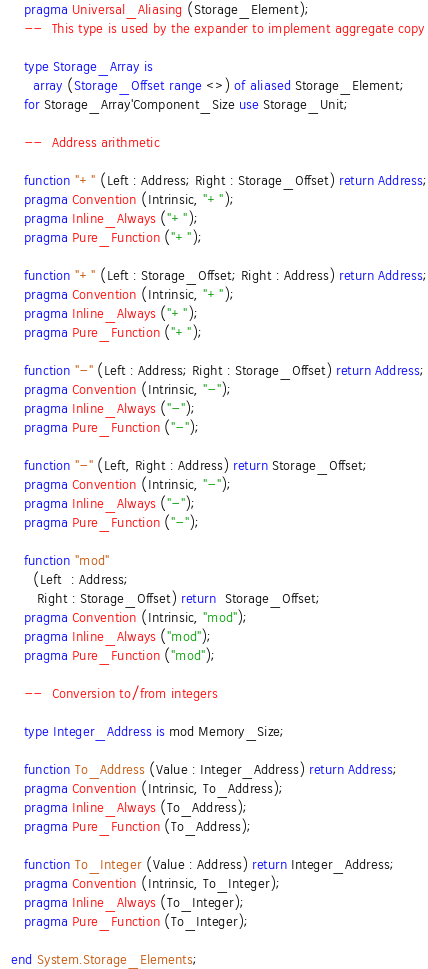Convert code to text. <code><loc_0><loc_0><loc_500><loc_500><_Ada_>   pragma Universal_Aliasing (Storage_Element);
   --  This type is used by the expander to implement aggregate copy

   type Storage_Array is
     array (Storage_Offset range <>) of aliased Storage_Element;
   for Storage_Array'Component_Size use Storage_Unit;

   --  Address arithmetic

   function "+" (Left : Address; Right : Storage_Offset) return Address;
   pragma Convention (Intrinsic, "+");
   pragma Inline_Always ("+");
   pragma Pure_Function ("+");

   function "+" (Left : Storage_Offset; Right : Address) return Address;
   pragma Convention (Intrinsic, "+");
   pragma Inline_Always ("+");
   pragma Pure_Function ("+");

   function "-" (Left : Address; Right : Storage_Offset) return Address;
   pragma Convention (Intrinsic, "-");
   pragma Inline_Always ("-");
   pragma Pure_Function ("-");

   function "-" (Left, Right : Address) return Storage_Offset;
   pragma Convention (Intrinsic, "-");
   pragma Inline_Always ("-");
   pragma Pure_Function ("-");

   function "mod"
     (Left  : Address;
      Right : Storage_Offset) return  Storage_Offset;
   pragma Convention (Intrinsic, "mod");
   pragma Inline_Always ("mod");
   pragma Pure_Function ("mod");

   --  Conversion to/from integers

   type Integer_Address is mod Memory_Size;

   function To_Address (Value : Integer_Address) return Address;
   pragma Convention (Intrinsic, To_Address);
   pragma Inline_Always (To_Address);
   pragma Pure_Function (To_Address);

   function To_Integer (Value : Address) return Integer_Address;
   pragma Convention (Intrinsic, To_Integer);
   pragma Inline_Always (To_Integer);
   pragma Pure_Function (To_Integer);

end System.Storage_Elements;
</code> 